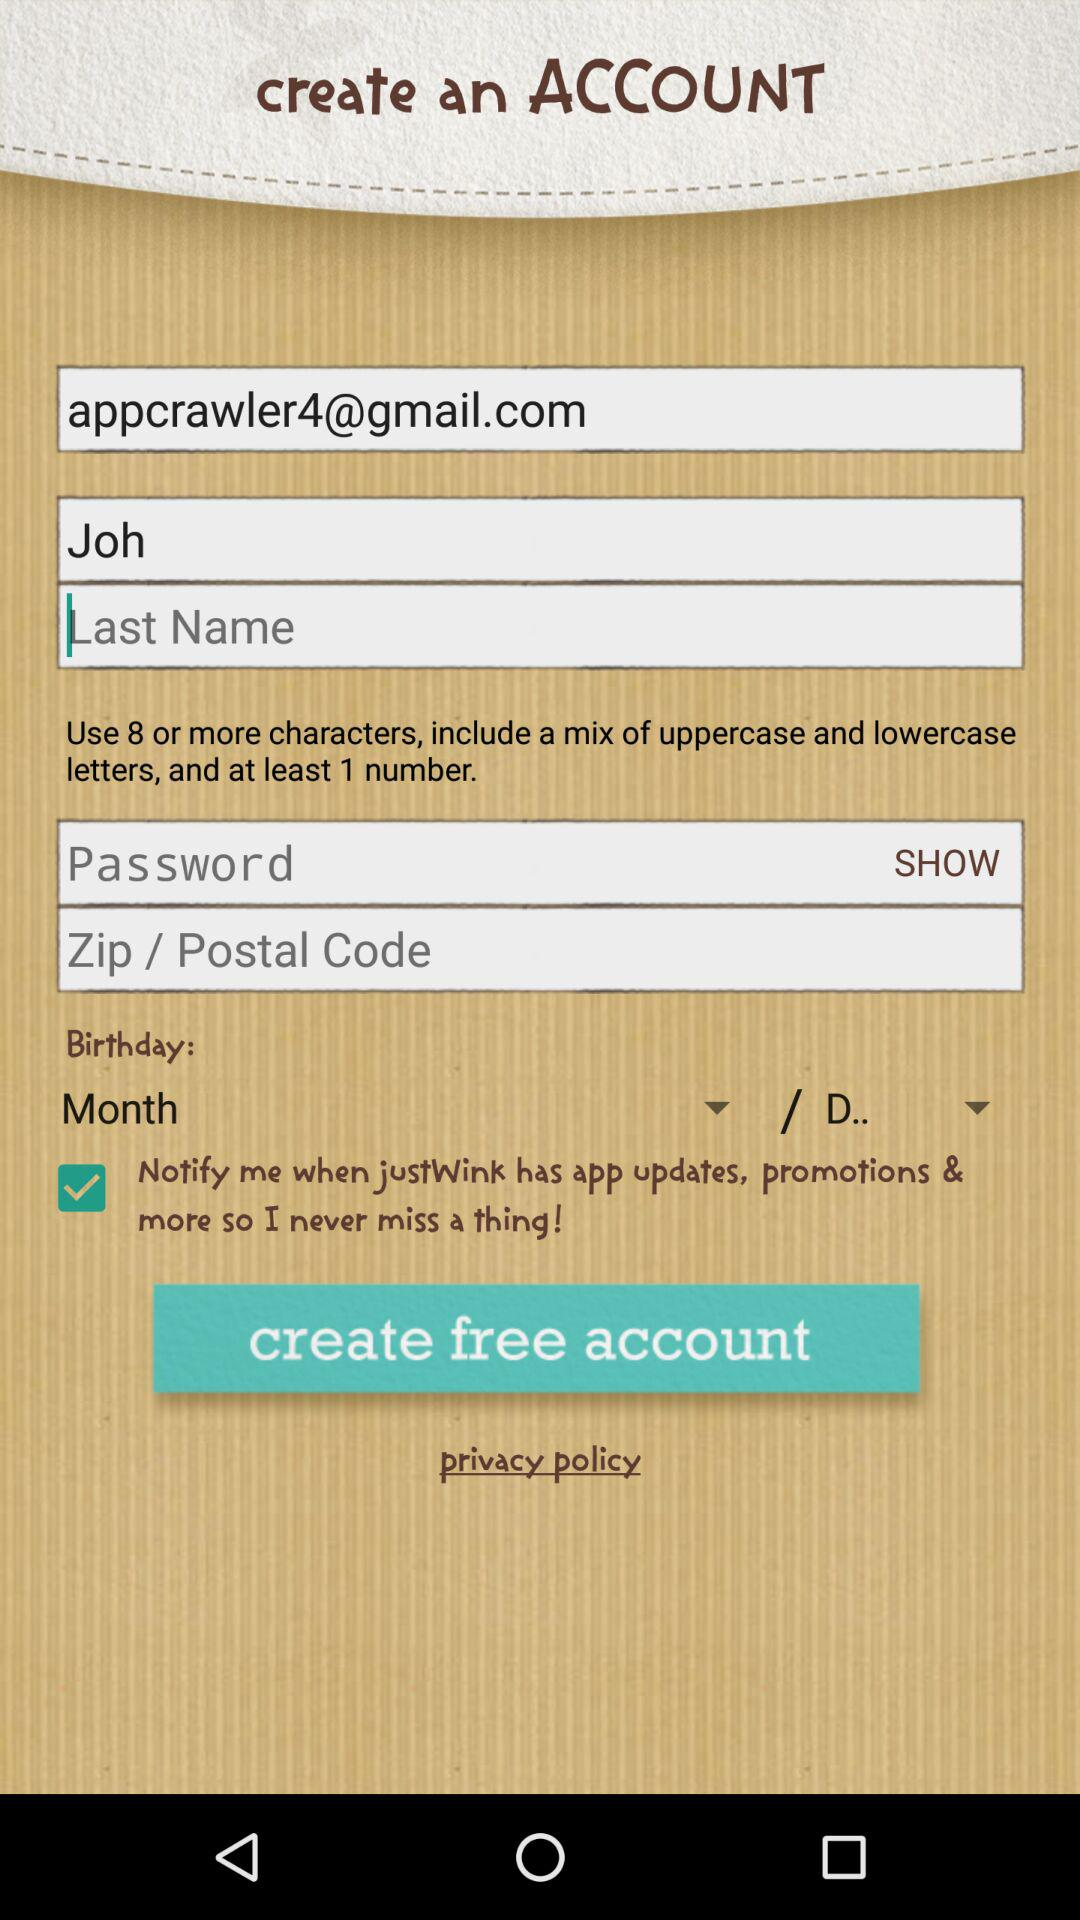When is the user's birthday?
When the provided information is insufficient, respond with <no answer>. <no answer> 